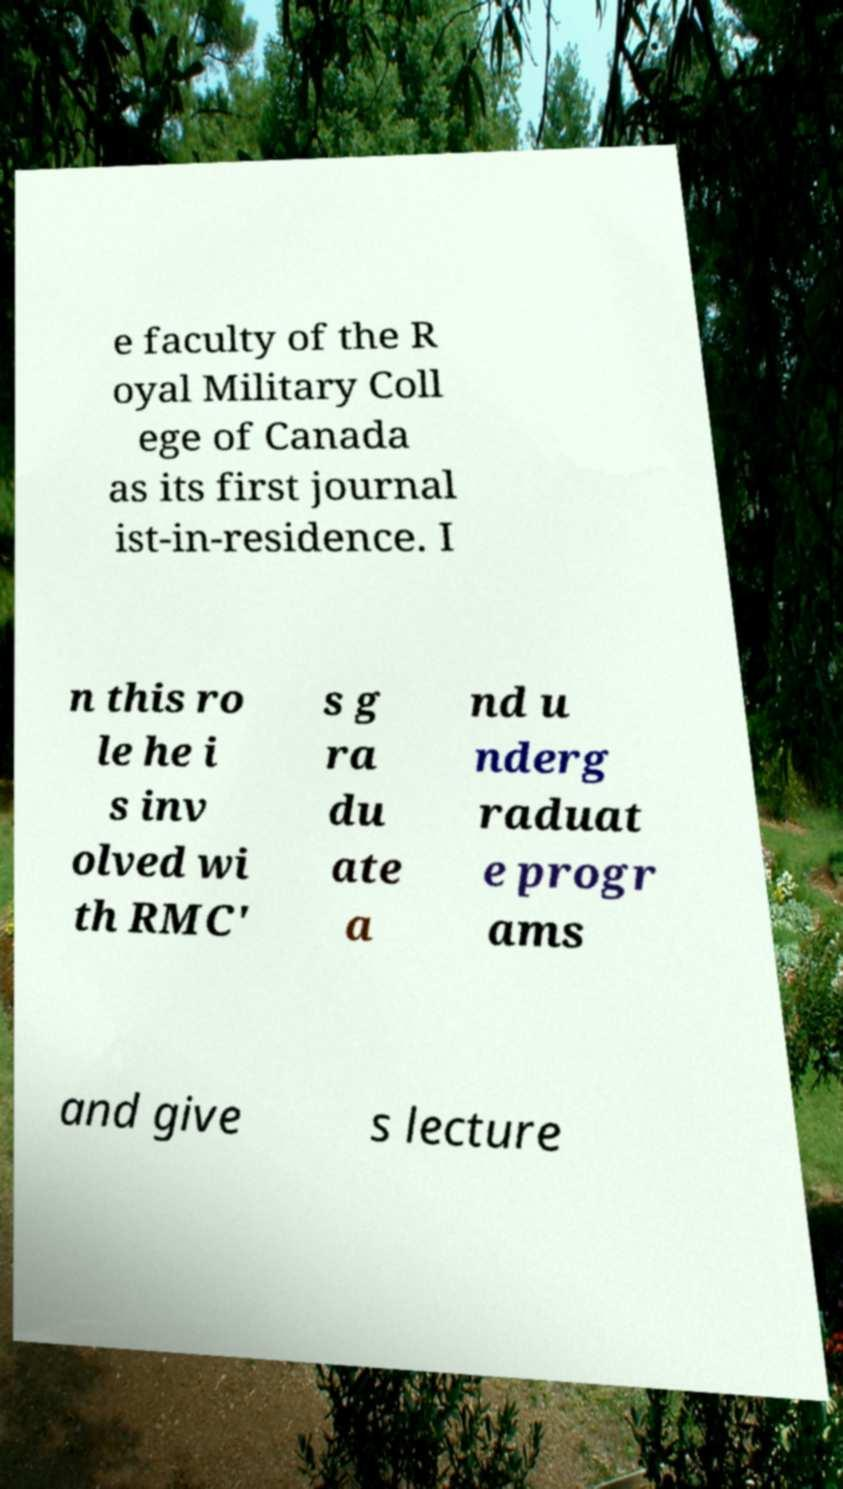What messages or text are displayed in this image? I need them in a readable, typed format. e faculty of the R oyal Military Coll ege of Canada as its first journal ist-in-residence. I n this ro le he i s inv olved wi th RMC' s g ra du ate a nd u nderg raduat e progr ams and give s lecture 